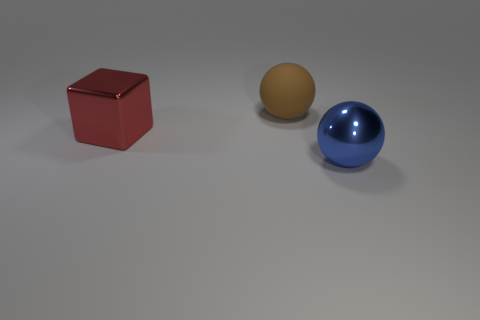Add 3 small yellow rubber things. How many objects exist? 6 Subtract all balls. How many objects are left? 1 Add 2 blue things. How many blue things exist? 3 Subtract 0 brown cylinders. How many objects are left? 3 Subtract all large brown things. Subtract all brown spheres. How many objects are left? 1 Add 2 big red shiny objects. How many big red shiny objects are left? 3 